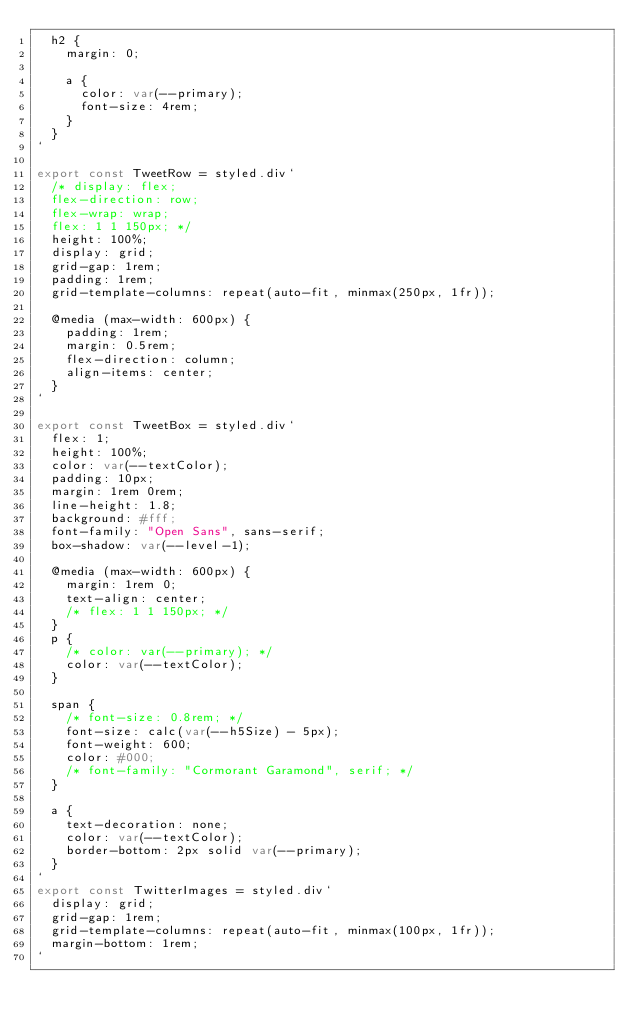Convert code to text. <code><loc_0><loc_0><loc_500><loc_500><_JavaScript_>  h2 {
    margin: 0;

    a {
      color: var(--primary);
      font-size: 4rem;
    }
  }
`

export const TweetRow = styled.div`
  /* display: flex;
  flex-direction: row;
  flex-wrap: wrap;
  flex: 1 1 150px; */
  height: 100%;
  display: grid;
  grid-gap: 1rem;
  padding: 1rem;
  grid-template-columns: repeat(auto-fit, minmax(250px, 1fr));

  @media (max-width: 600px) {
    padding: 1rem;
    margin: 0.5rem;
    flex-direction: column;
    align-items: center;
  }
`

export const TweetBox = styled.div`
  flex: 1;
  height: 100%;
  color: var(--textColor);
  padding: 10px;
  margin: 1rem 0rem;
  line-height: 1.8;
  background: #fff;
  font-family: "Open Sans", sans-serif;
  box-shadow: var(--level-1);

  @media (max-width: 600px) {
    margin: 1rem 0;
    text-align: center;
    /* flex: 1 1 150px; */
  }
  p {
    /* color: var(--primary); */
    color: var(--textColor);
  }

  span {
    /* font-size: 0.8rem; */
    font-size: calc(var(--h5Size) - 5px);
    font-weight: 600;
    color: #000;
    /* font-family: "Cormorant Garamond", serif; */
  }

  a {
    text-decoration: none;
    color: var(--textColor);
    border-bottom: 2px solid var(--primary);
  }
`
export const TwitterImages = styled.div`
  display: grid;
  grid-gap: 1rem;
  grid-template-columns: repeat(auto-fit, minmax(100px, 1fr));
  margin-bottom: 1rem;
`
</code> 